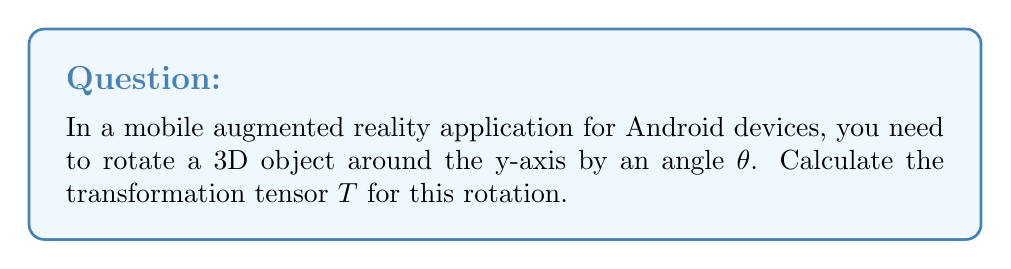Give your solution to this math problem. To solve this problem, we'll follow these steps:

1. Recall the general form of a 3D rotation matrix around the y-axis:

   $$R_y(\theta) = \begin{pmatrix}
   \cos\theta & 0 & \sin\theta \\
   0 & 1 & 0 \\
   -\sin\theta & 0 & \cos\theta
   \end{pmatrix}$$

2. In tensor notation, this rotation can be represented as a rank-2 tensor $T^i_j$, where $i$ and $j$ range from 1 to 3, corresponding to the x, y, and z axes respectively.

3. The components of the transformation tensor $T^i_j$ are:

   $T^1_1 = \cos\theta$
   $T^1_3 = \sin\theta$
   $T^2_2 = 1$
   $T^3_1 = -\sin\theta$
   $T^3_3 = \cos\theta$

   All other components are zero.

4. We can write this tensor in index notation as:

   $$T^i_j = \cos\theta(\delta^i_1\delta^1_j + \delta^i_3\delta^3_j) + \sin\theta(\delta^i_1\delta^3_j - \delta^i_3\delta^1_j) + \delta^i_2\delta^2_j$$

   Where $\delta^i_j$ is the Kronecker delta function.

5. This tensor can be applied to a vector $v^i$ to perform the rotation:

   $$v'^i = T^i_j v^j$$

   Where $v'^i$ is the rotated vector.
Answer: $T^i_j = \cos\theta(\delta^i_1\delta^1_j + \delta^i_3\delta^3_j) + \sin\theta(\delta^i_1\delta^3_j - \delta^i_3\delta^1_j) + \delta^i_2\delta^2_j$ 